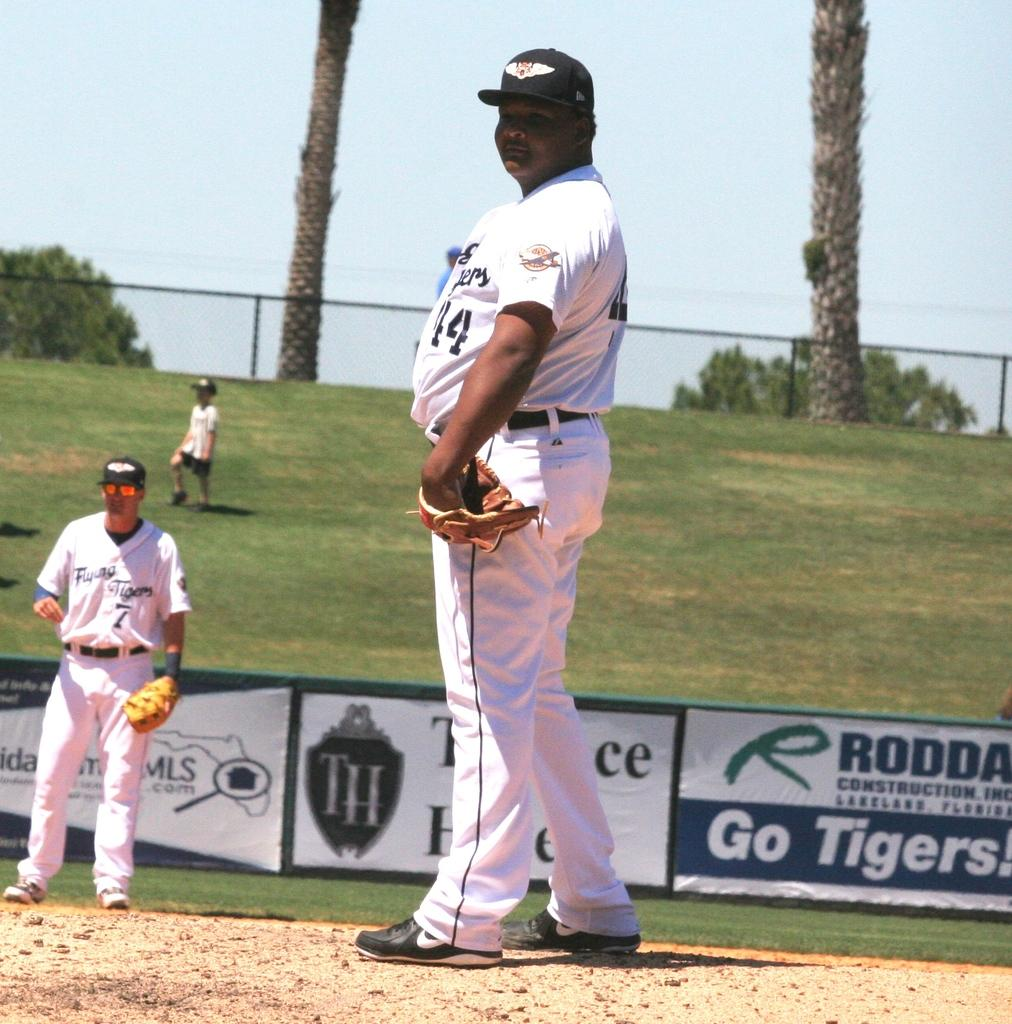Provide a one-sentence caption for the provided image. An advertisement on a baseball field urges the team on with a message of Go Tigers. 